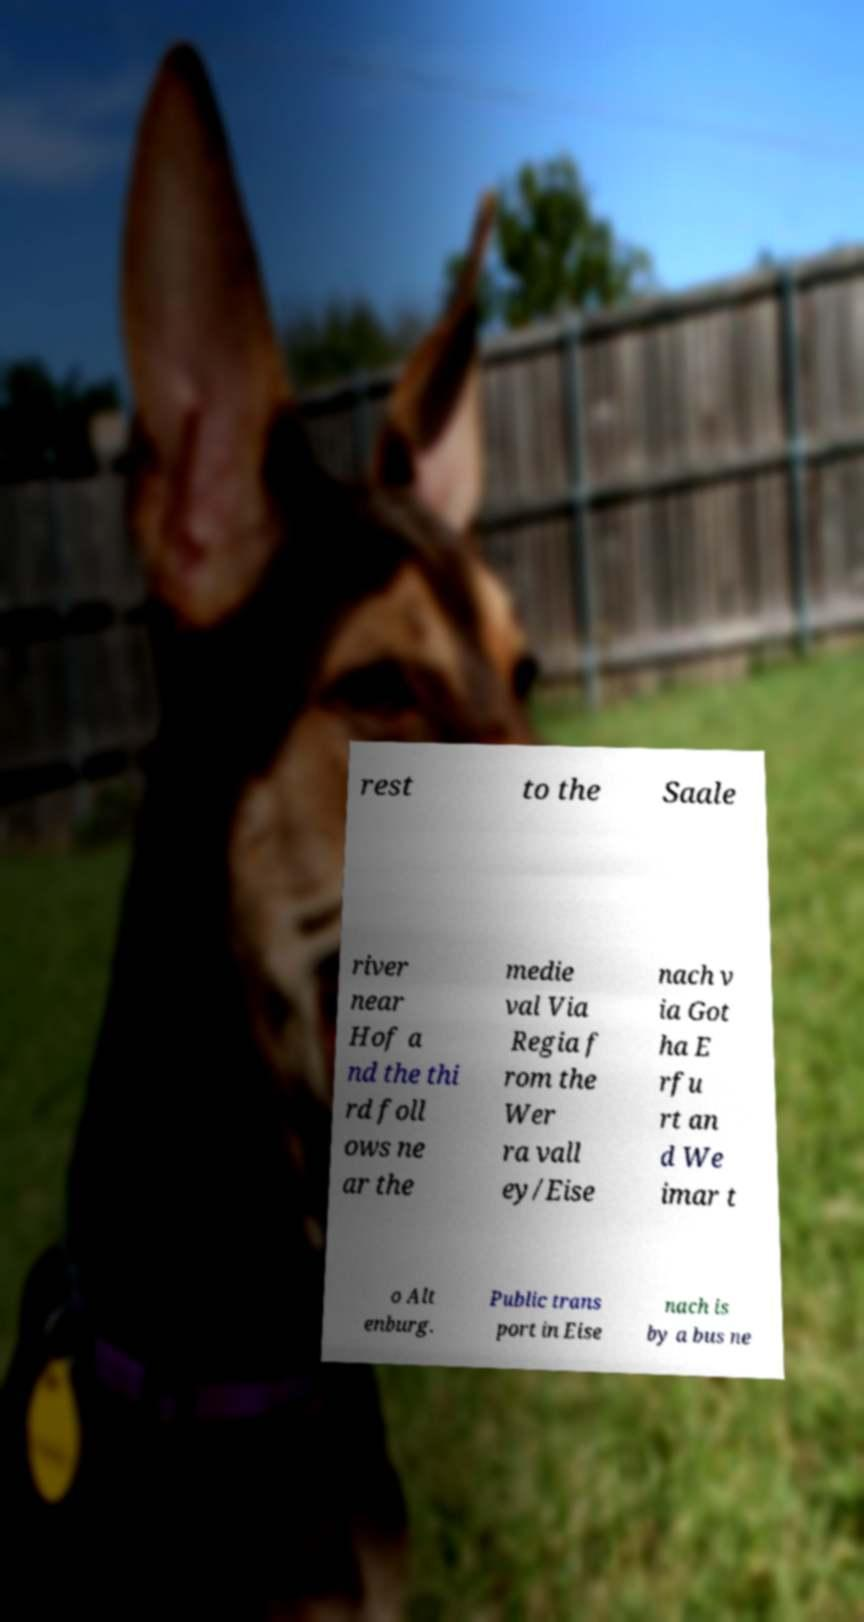Can you read and provide the text displayed in the image?This photo seems to have some interesting text. Can you extract and type it out for me? rest to the Saale river near Hof a nd the thi rd foll ows ne ar the medie val Via Regia f rom the Wer ra vall ey/Eise nach v ia Got ha E rfu rt an d We imar t o Alt enburg. Public trans port in Eise nach is by a bus ne 